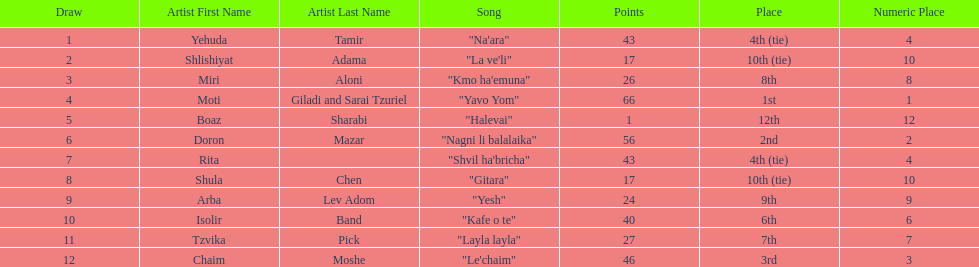What is the name of the song listed before the song "yesh"? "Gitara". 